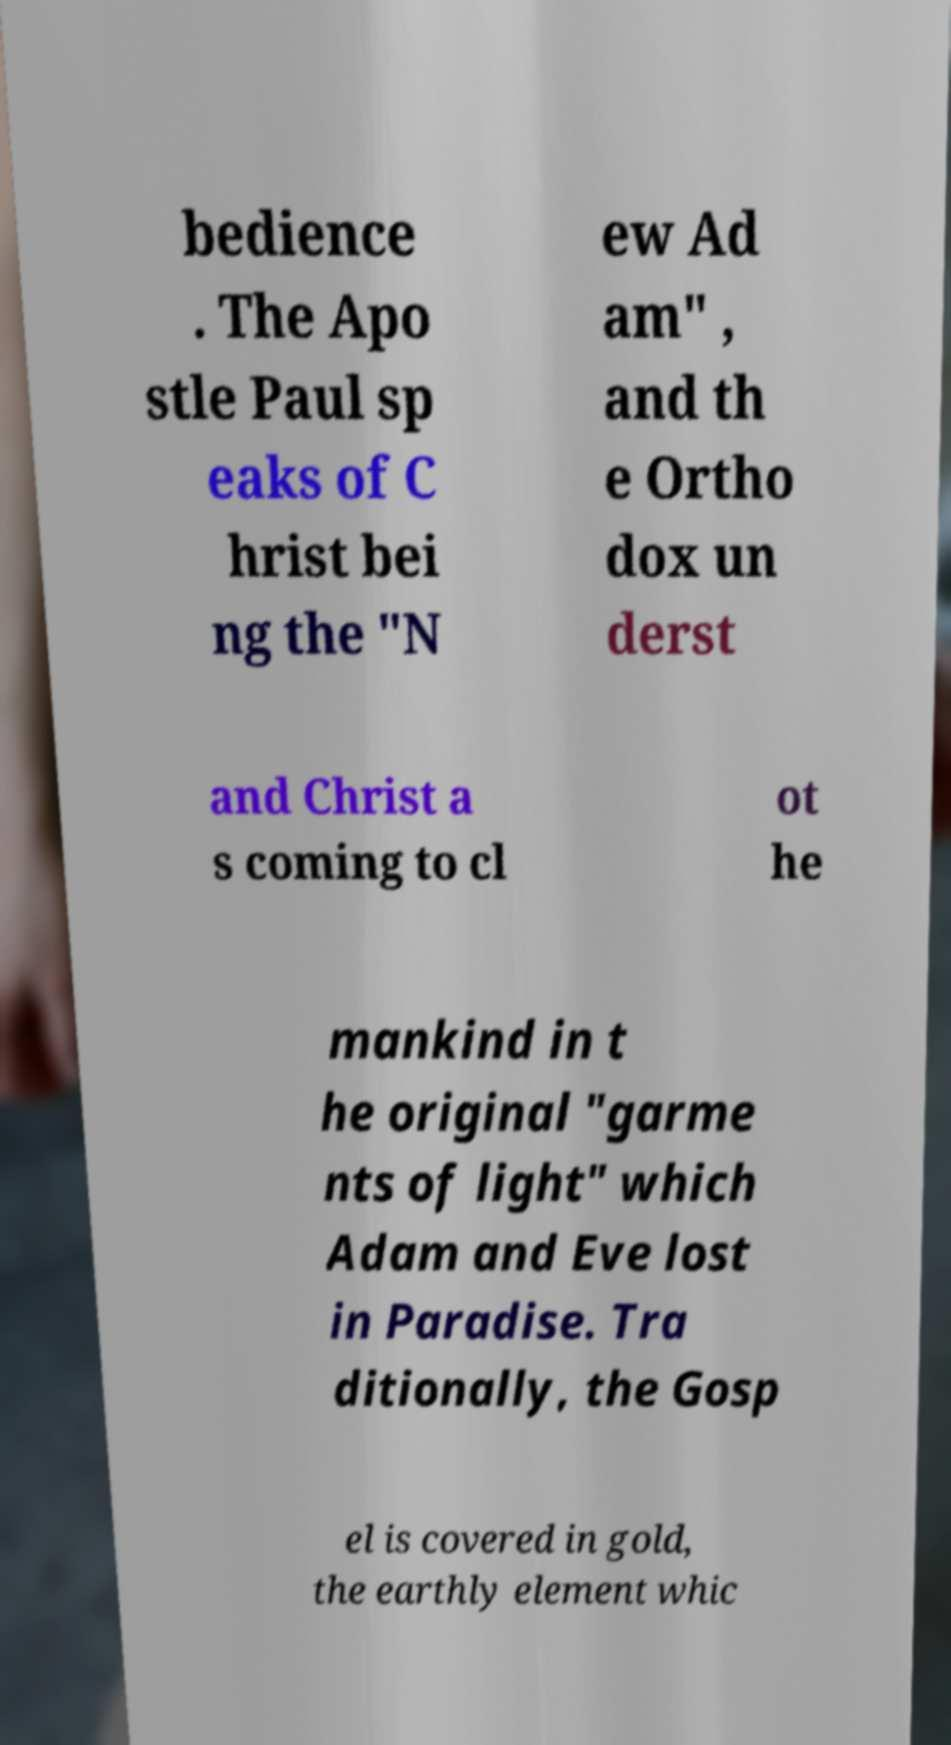Please read and relay the text visible in this image. What does it say? bedience . The Apo stle Paul sp eaks of C hrist bei ng the "N ew Ad am" , and th e Ortho dox un derst and Christ a s coming to cl ot he mankind in t he original "garme nts of light" which Adam and Eve lost in Paradise. Tra ditionally, the Gosp el is covered in gold, the earthly element whic 